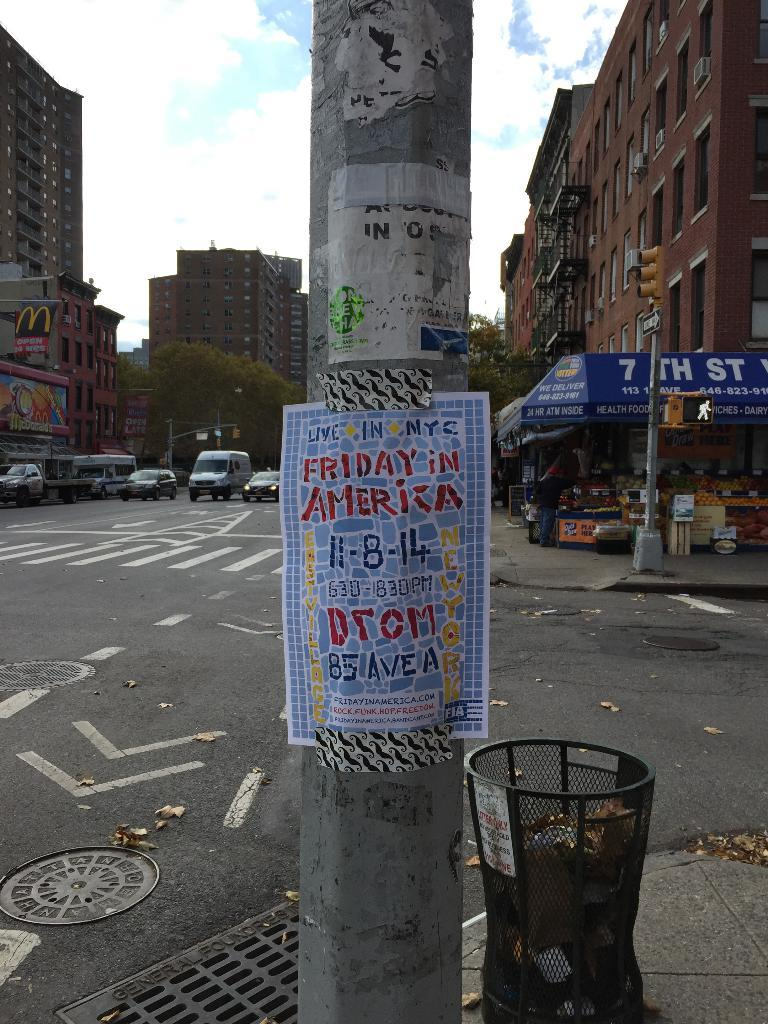<image>
Create a compact narrative representing the image presented. A poster is up on a pole outside that says "Friday in America" 